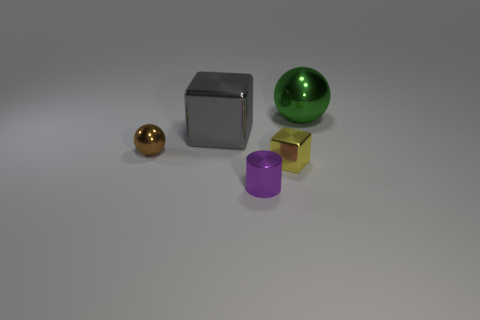Add 2 big blue rubber cubes. How many objects exist? 7 Subtract all spheres. How many objects are left? 3 Subtract all gray metal objects. Subtract all small yellow metallic objects. How many objects are left? 3 Add 3 yellow objects. How many yellow objects are left? 4 Add 4 large objects. How many large objects exist? 6 Subtract 0 green cylinders. How many objects are left? 5 